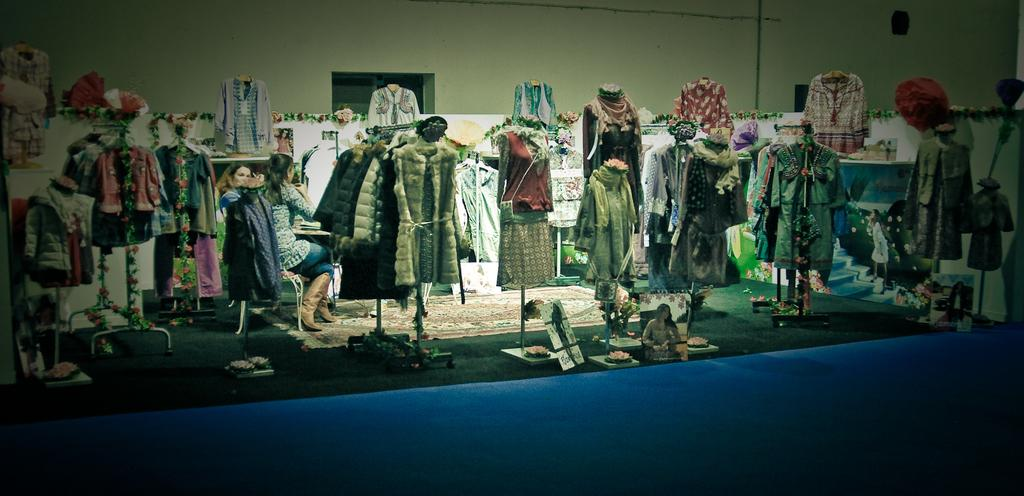What is located in the center of the image? There is a wall in the center of the image. What can be seen hanging on the wall? Clothes are present in the image. What structures are visible in the image? Stands and a staircase are visible in the image. How many people are in the image? There are two persons in the image. What other objects can be seen in the image? There are a few other objects in the image. What type of prose is being recited by the persons in the image? There is no indication in the image that any prose is being recited, as the focus is on the wall, clothes, stands, and staircase. What route are the persons taking in the image? There is no route visible in the image, as it is focused on the wall and other objects. 